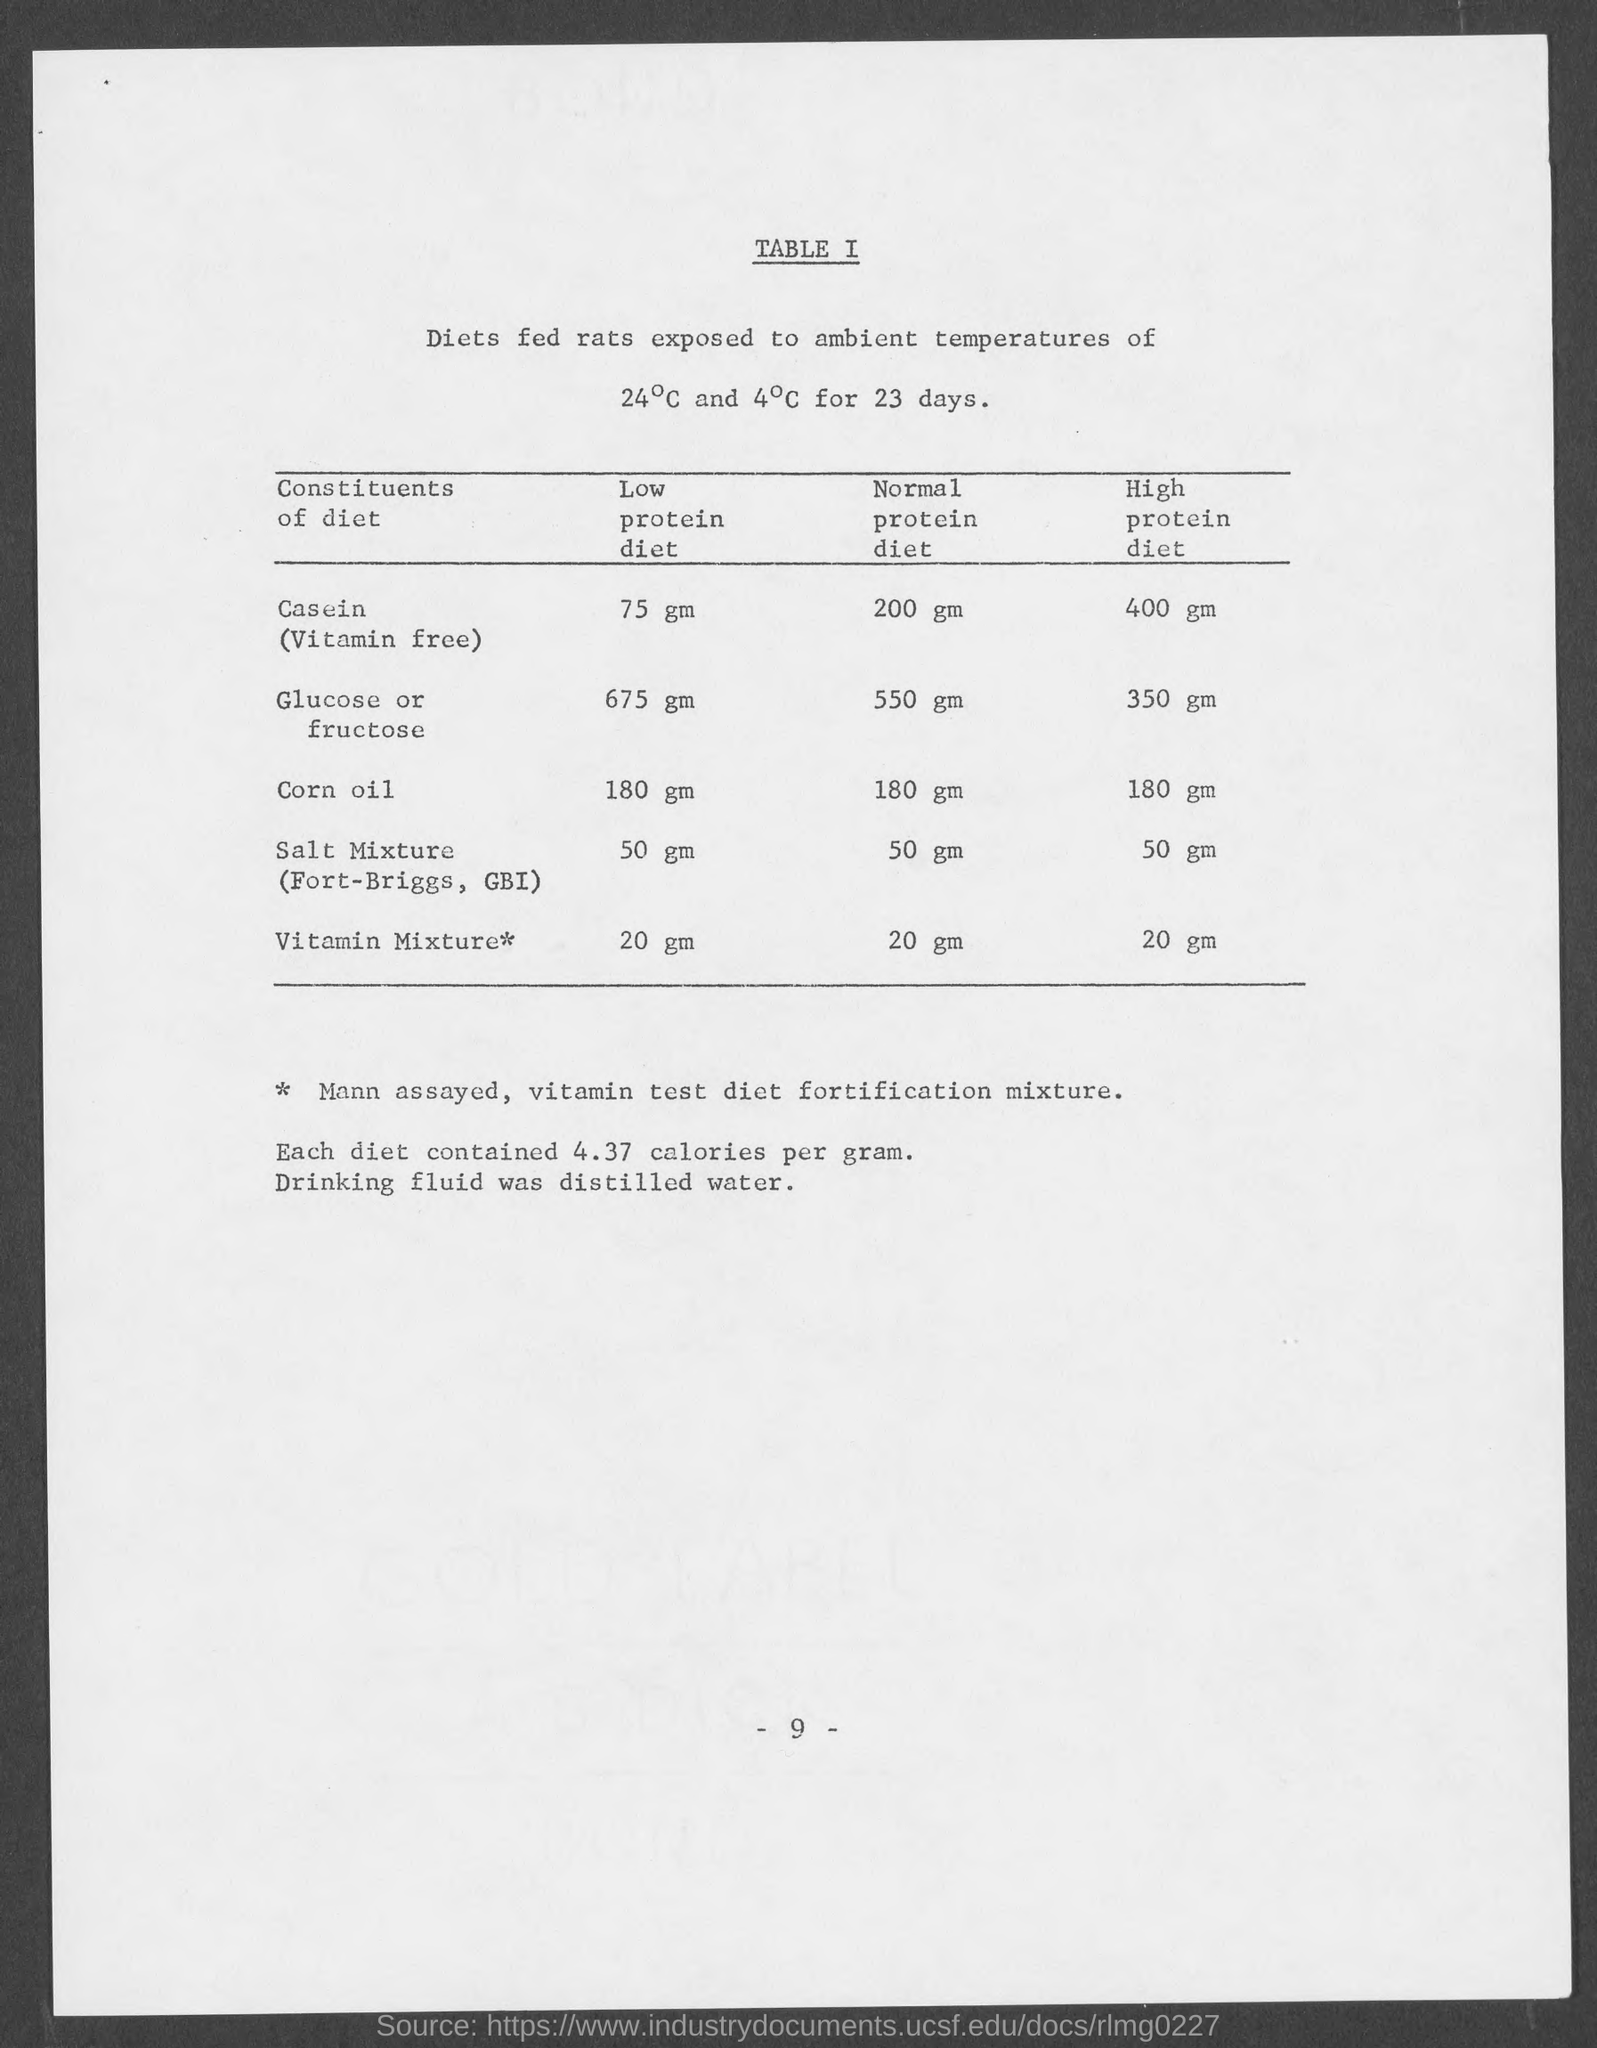What is the page number at bottom of the page ?
Keep it short and to the point. 9. 